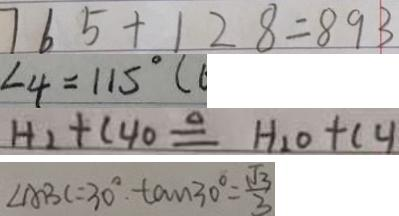Convert formula to latex. <formula><loc_0><loc_0><loc_500><loc_500>7 6 5 + 1 2 8 = 8 9 3 
 \angle 4 = 1 1 5 ^ { \circ } ( 
 H _ { 2 } + C _ { 4 } O \Delta q H _ { 2 } O + C _ { 4 } 
 \angle A B C = 3 0 ^ { \circ } \tan 3 0 ^ { \circ } = \frac { \sqrt { 3 } } { 3 }</formula> 